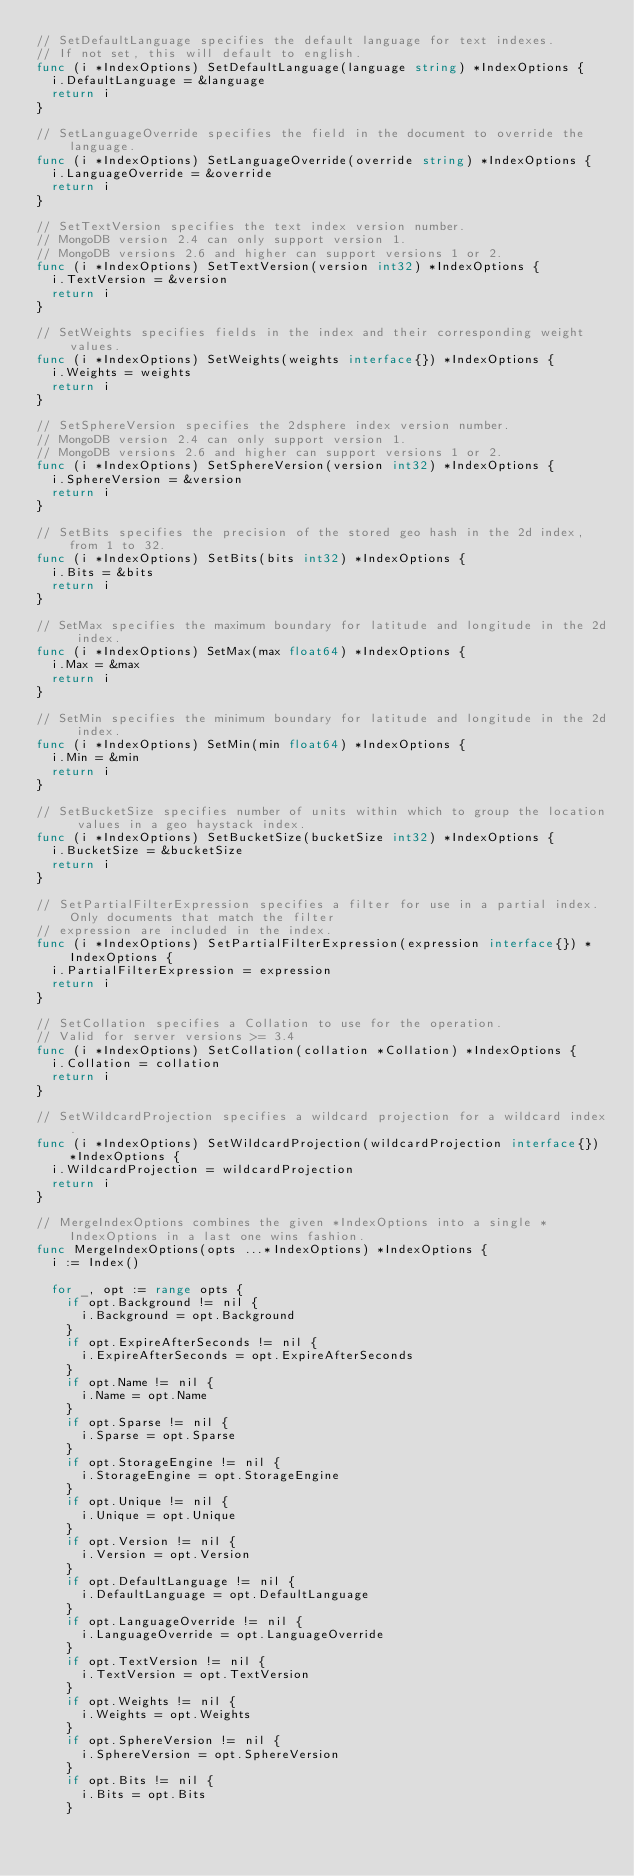Convert code to text. <code><loc_0><loc_0><loc_500><loc_500><_Go_>// SetDefaultLanguage specifies the default language for text indexes.
// If not set, this will default to english.
func (i *IndexOptions) SetDefaultLanguage(language string) *IndexOptions {
	i.DefaultLanguage = &language
	return i
}

// SetLanguageOverride specifies the field in the document to override the language.
func (i *IndexOptions) SetLanguageOverride(override string) *IndexOptions {
	i.LanguageOverride = &override
	return i
}

// SetTextVersion specifies the text index version number.
// MongoDB version 2.4 can only support version 1.
// MongoDB versions 2.6 and higher can support versions 1 or 2.
func (i *IndexOptions) SetTextVersion(version int32) *IndexOptions {
	i.TextVersion = &version
	return i
}

// SetWeights specifies fields in the index and their corresponding weight values.
func (i *IndexOptions) SetWeights(weights interface{}) *IndexOptions {
	i.Weights = weights
	return i
}

// SetSphereVersion specifies the 2dsphere index version number.
// MongoDB version 2.4 can only support version 1.
// MongoDB versions 2.6 and higher can support versions 1 or 2.
func (i *IndexOptions) SetSphereVersion(version int32) *IndexOptions {
	i.SphereVersion = &version
	return i
}

// SetBits specifies the precision of the stored geo hash in the 2d index, from 1 to 32.
func (i *IndexOptions) SetBits(bits int32) *IndexOptions {
	i.Bits = &bits
	return i
}

// SetMax specifies the maximum boundary for latitude and longitude in the 2d index.
func (i *IndexOptions) SetMax(max float64) *IndexOptions {
	i.Max = &max
	return i
}

// SetMin specifies the minimum boundary for latitude and longitude in the 2d index.
func (i *IndexOptions) SetMin(min float64) *IndexOptions {
	i.Min = &min
	return i
}

// SetBucketSize specifies number of units within which to group the location values in a geo haystack index.
func (i *IndexOptions) SetBucketSize(bucketSize int32) *IndexOptions {
	i.BucketSize = &bucketSize
	return i
}

// SetPartialFilterExpression specifies a filter for use in a partial index. Only documents that match the filter
// expression are included in the index.
func (i *IndexOptions) SetPartialFilterExpression(expression interface{}) *IndexOptions {
	i.PartialFilterExpression = expression
	return i
}

// SetCollation specifies a Collation to use for the operation.
// Valid for server versions >= 3.4
func (i *IndexOptions) SetCollation(collation *Collation) *IndexOptions {
	i.Collation = collation
	return i
}

// SetWildcardProjection specifies a wildcard projection for a wildcard index.
func (i *IndexOptions) SetWildcardProjection(wildcardProjection interface{}) *IndexOptions {
	i.WildcardProjection = wildcardProjection
	return i
}

// MergeIndexOptions combines the given *IndexOptions into a single *IndexOptions in a last one wins fashion.
func MergeIndexOptions(opts ...*IndexOptions) *IndexOptions {
	i := Index()

	for _, opt := range opts {
		if opt.Background != nil {
			i.Background = opt.Background
		}
		if opt.ExpireAfterSeconds != nil {
			i.ExpireAfterSeconds = opt.ExpireAfterSeconds
		}
		if opt.Name != nil {
			i.Name = opt.Name
		}
		if opt.Sparse != nil {
			i.Sparse = opt.Sparse
		}
		if opt.StorageEngine != nil {
			i.StorageEngine = opt.StorageEngine
		}
		if opt.Unique != nil {
			i.Unique = opt.Unique
		}
		if opt.Version != nil {
			i.Version = opt.Version
		}
		if opt.DefaultLanguage != nil {
			i.DefaultLanguage = opt.DefaultLanguage
		}
		if opt.LanguageOverride != nil {
			i.LanguageOverride = opt.LanguageOverride
		}
		if opt.TextVersion != nil {
			i.TextVersion = opt.TextVersion
		}
		if opt.Weights != nil {
			i.Weights = opt.Weights
		}
		if opt.SphereVersion != nil {
			i.SphereVersion = opt.SphereVersion
		}
		if opt.Bits != nil {
			i.Bits = opt.Bits
		}</code> 